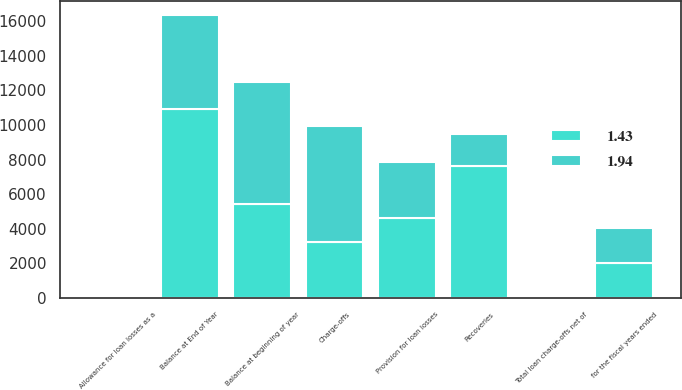<chart> <loc_0><loc_0><loc_500><loc_500><stacked_bar_chart><ecel><fcel>for the fiscal years ended<fcel>Balance at beginning of year<fcel>Provision for loan losses<fcel>Charge-offs<fcel>Recoveries<fcel>Balance at End of Year<fcel>Total loan charge-offs net of<fcel>Allowance for loan losses as a<nl><fcel>1.43<fcel>2011<fcel>5449<fcel>4608<fcel>3252<fcel>7603<fcel>10894<fcel>2.09<fcel>1.94<nl><fcel>1.94<fcel>2010<fcel>7026<fcel>3252<fcel>6697<fcel>1868<fcel>5449<fcel>1.31<fcel>1.43<nl></chart> 